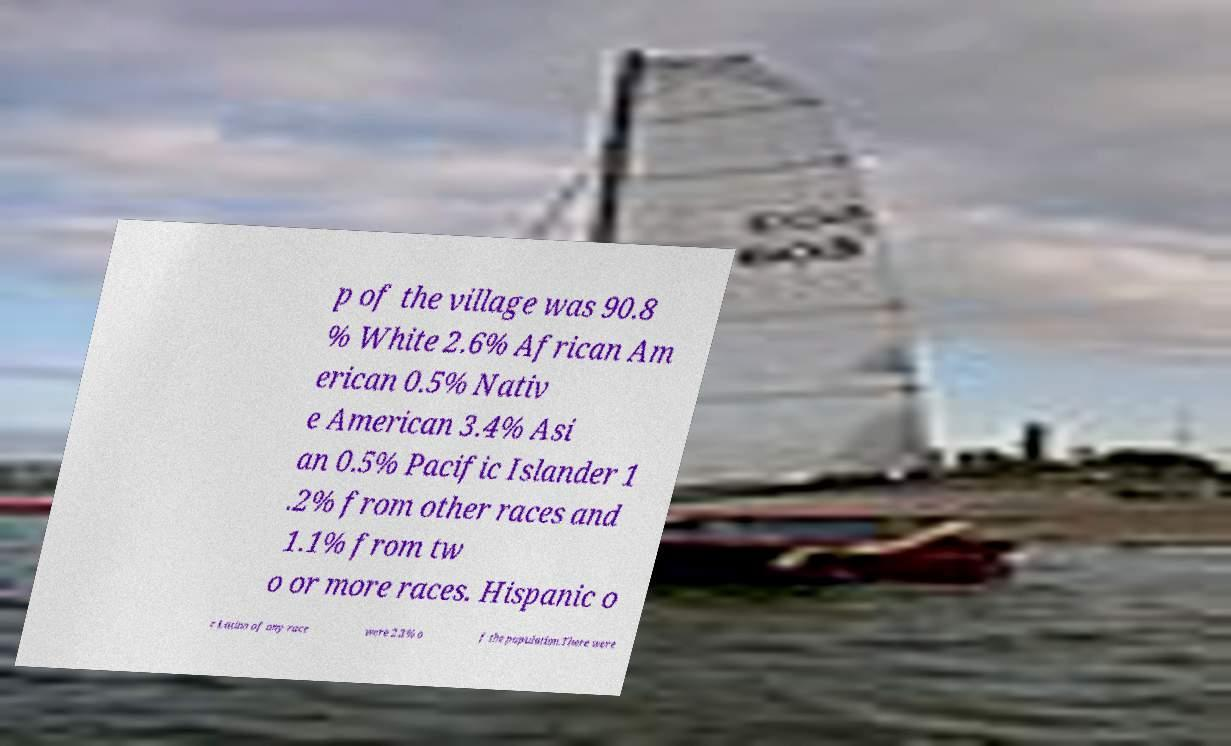For documentation purposes, I need the text within this image transcribed. Could you provide that? p of the village was 90.8 % White 2.6% African Am erican 0.5% Nativ e American 3.4% Asi an 0.5% Pacific Islander 1 .2% from other races and 1.1% from tw o or more races. Hispanic o r Latino of any race were 2.3% o f the population.There were 